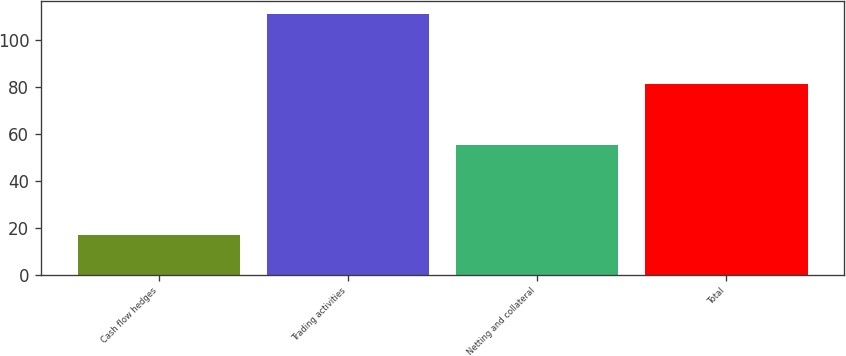Convert chart. <chart><loc_0><loc_0><loc_500><loc_500><bar_chart><fcel>Cash flow hedges<fcel>Trading activities<fcel>Netting and collateral<fcel>Total<nl><fcel>17<fcel>111<fcel>55<fcel>81<nl></chart> 